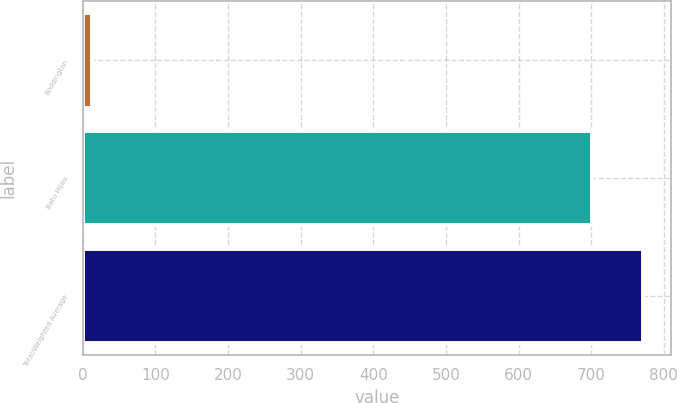<chart> <loc_0><loc_0><loc_500><loc_500><bar_chart><fcel>Boddington<fcel>Batu Hijau<fcel>Total/Weighted Average<nl><fcel>13<fcel>701<fcel>771.1<nl></chart> 